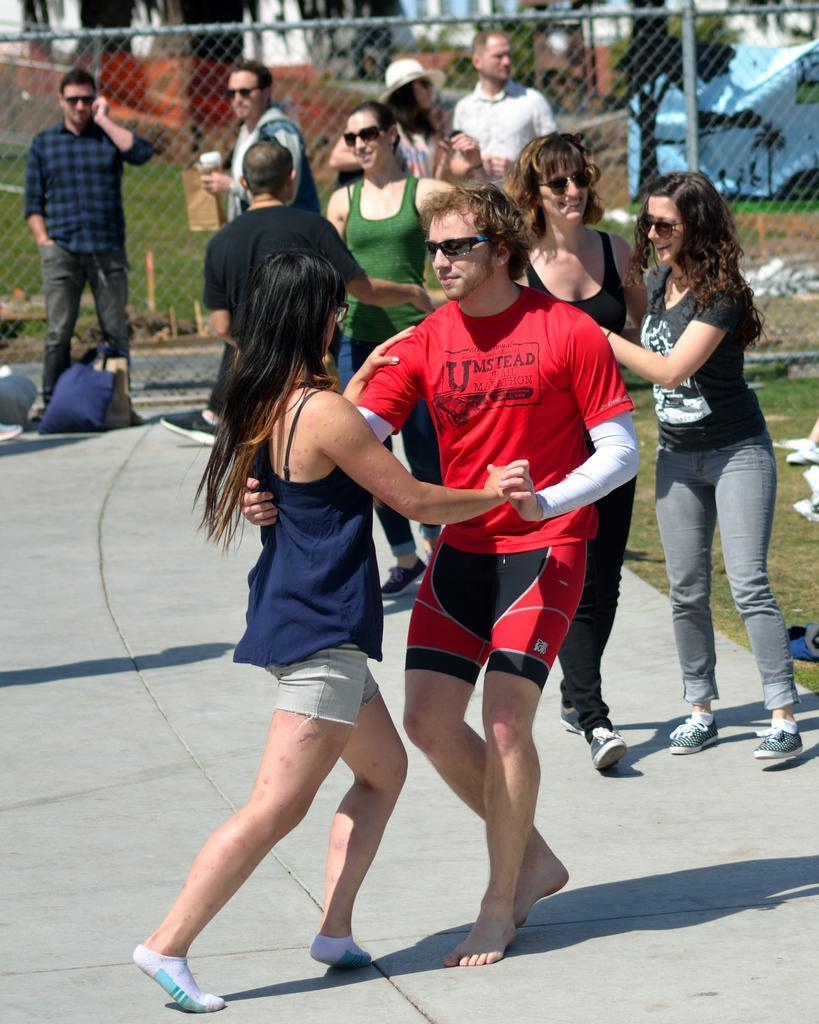Can you describe this image briefly? In this image, we can see a group of people wearing clothes and standing in front of the fencing. There are two persons in the middle of the image dancing on the floor. 